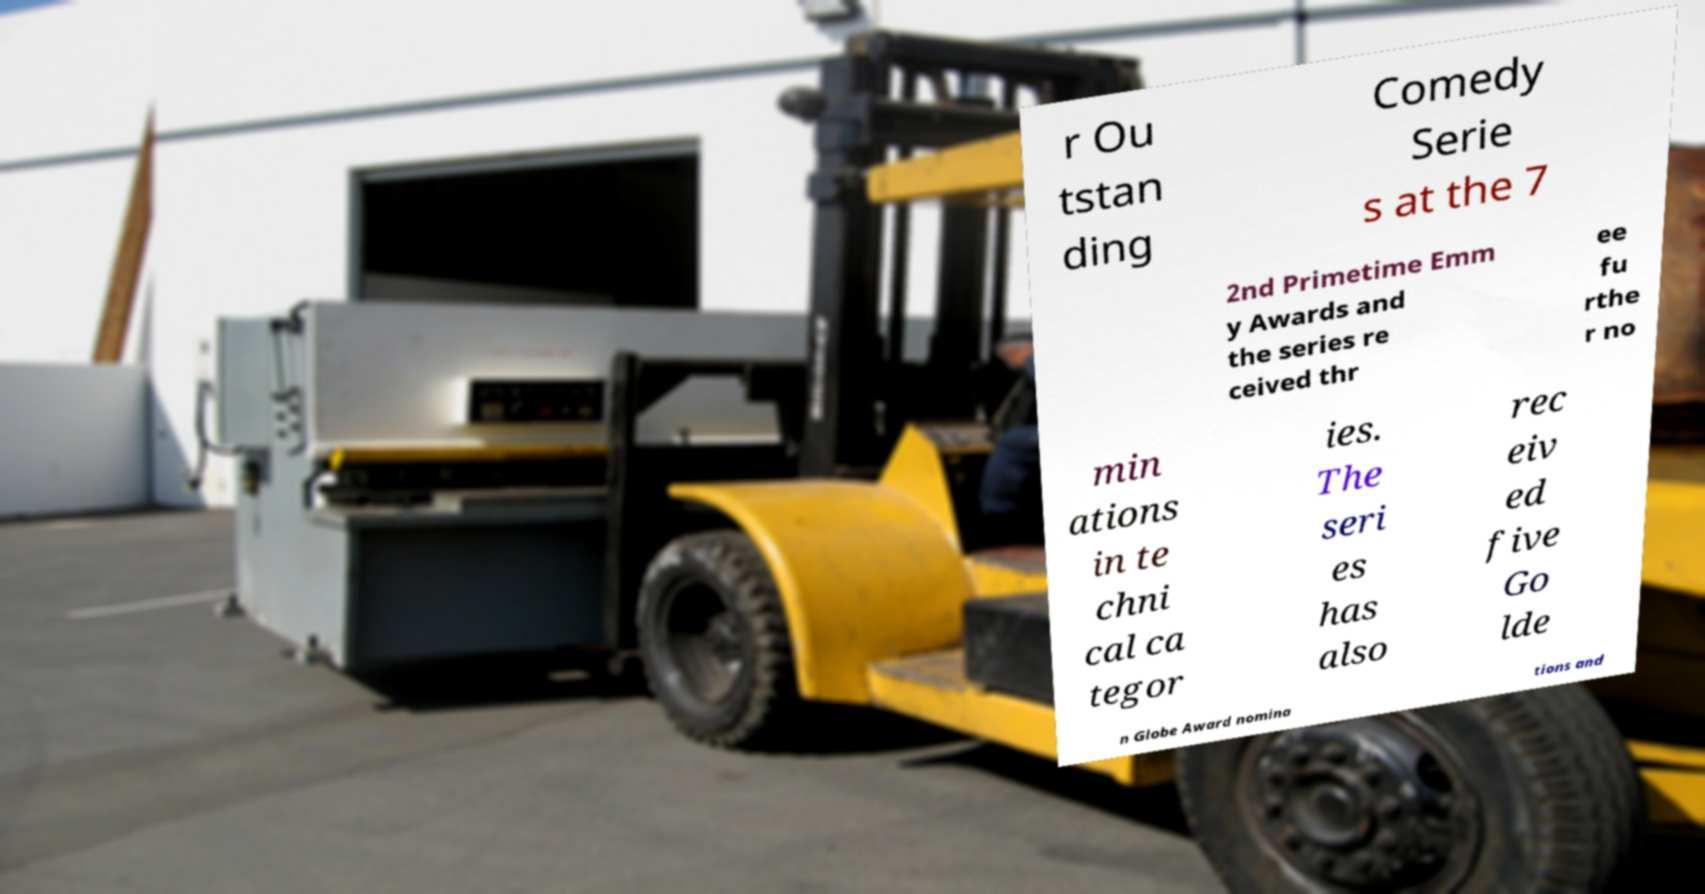Can you accurately transcribe the text from the provided image for me? r Ou tstan ding Comedy Serie s at the 7 2nd Primetime Emm y Awards and the series re ceived thr ee fu rthe r no min ations in te chni cal ca tegor ies. The seri es has also rec eiv ed five Go lde n Globe Award nomina tions and 